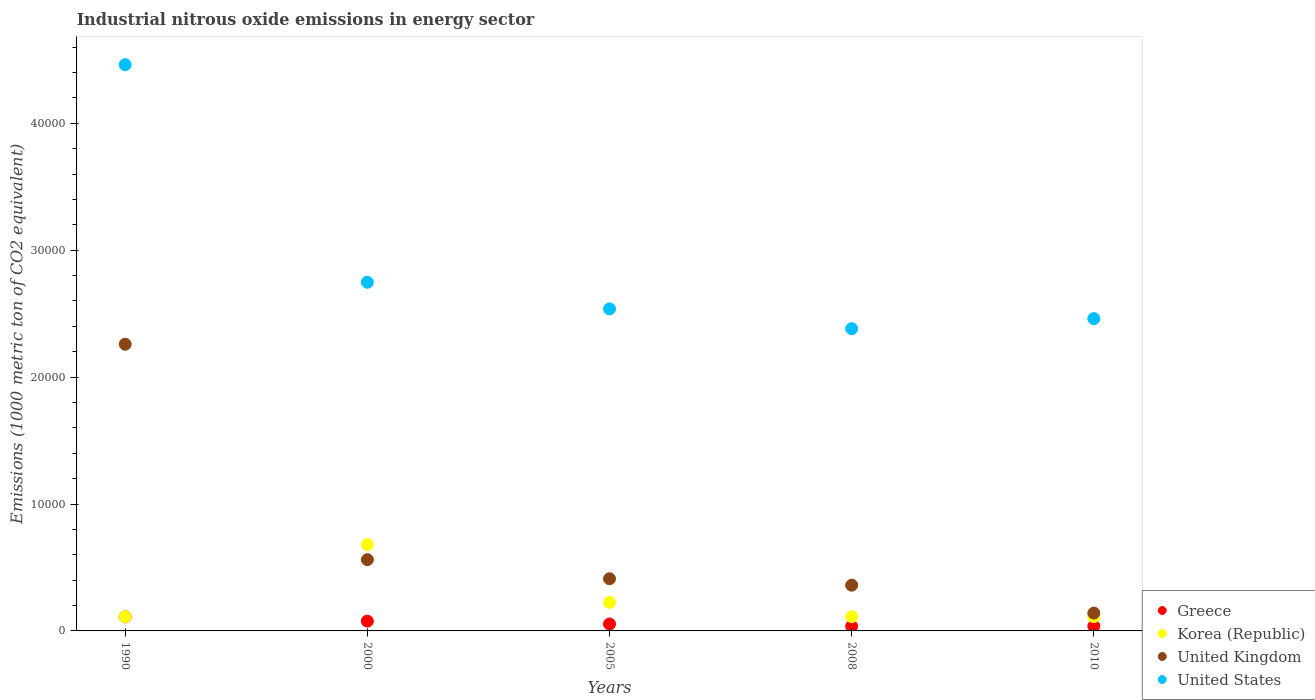How many different coloured dotlines are there?
Make the answer very short. 4. Is the number of dotlines equal to the number of legend labels?
Give a very brief answer. Yes. What is the amount of industrial nitrous oxide emitted in United Kingdom in 2005?
Make the answer very short. 4111.2. Across all years, what is the maximum amount of industrial nitrous oxide emitted in Korea (Republic)?
Ensure brevity in your answer.  6803. Across all years, what is the minimum amount of industrial nitrous oxide emitted in Korea (Republic)?
Provide a short and direct response. 1112.3. In which year was the amount of industrial nitrous oxide emitted in United Kingdom maximum?
Give a very brief answer. 1990. What is the total amount of industrial nitrous oxide emitted in United Kingdom in the graph?
Your response must be concise. 3.73e+04. What is the difference between the amount of industrial nitrous oxide emitted in Korea (Republic) in 2005 and that in 2008?
Make the answer very short. 1125.6. What is the difference between the amount of industrial nitrous oxide emitted in Korea (Republic) in 2005 and the amount of industrial nitrous oxide emitted in United Kingdom in 2010?
Make the answer very short. 840.9. What is the average amount of industrial nitrous oxide emitted in United Kingdom per year?
Offer a very short reply. 7466.28. In the year 2000, what is the difference between the amount of industrial nitrous oxide emitted in Greece and amount of industrial nitrous oxide emitted in Korea (Republic)?
Give a very brief answer. -6032. In how many years, is the amount of industrial nitrous oxide emitted in United Kingdom greater than 8000 1000 metric ton?
Offer a terse response. 1. What is the ratio of the amount of industrial nitrous oxide emitted in Greece in 1990 to that in 2000?
Ensure brevity in your answer.  1.44. Is the difference between the amount of industrial nitrous oxide emitted in Greece in 1990 and 2010 greater than the difference between the amount of industrial nitrous oxide emitted in Korea (Republic) in 1990 and 2010?
Provide a short and direct response. Yes. What is the difference between the highest and the second highest amount of industrial nitrous oxide emitted in United States?
Provide a short and direct response. 1.71e+04. What is the difference between the highest and the lowest amount of industrial nitrous oxide emitted in Greece?
Your answer should be very brief. 741.7. Is the sum of the amount of industrial nitrous oxide emitted in Korea (Republic) in 2000 and 2010 greater than the maximum amount of industrial nitrous oxide emitted in United Kingdom across all years?
Provide a short and direct response. No. Is it the case that in every year, the sum of the amount of industrial nitrous oxide emitted in United States and amount of industrial nitrous oxide emitted in Greece  is greater than the sum of amount of industrial nitrous oxide emitted in United Kingdom and amount of industrial nitrous oxide emitted in Korea (Republic)?
Provide a short and direct response. Yes. Is it the case that in every year, the sum of the amount of industrial nitrous oxide emitted in United Kingdom and amount of industrial nitrous oxide emitted in Greece  is greater than the amount of industrial nitrous oxide emitted in Korea (Republic)?
Keep it short and to the point. No. Is the amount of industrial nitrous oxide emitted in Greece strictly greater than the amount of industrial nitrous oxide emitted in United Kingdom over the years?
Your answer should be compact. No. How many years are there in the graph?
Your answer should be compact. 5. What is the difference between two consecutive major ticks on the Y-axis?
Give a very brief answer. 10000. Are the values on the major ticks of Y-axis written in scientific E-notation?
Give a very brief answer. No. Does the graph contain grids?
Keep it short and to the point. No. How many legend labels are there?
Your answer should be compact. 4. What is the title of the graph?
Provide a short and direct response. Industrial nitrous oxide emissions in energy sector. What is the label or title of the X-axis?
Offer a very short reply. Years. What is the label or title of the Y-axis?
Provide a succinct answer. Emissions (1000 metric ton of CO2 equivalent). What is the Emissions (1000 metric ton of CO2 equivalent) of Greece in 1990?
Your answer should be compact. 1109.1. What is the Emissions (1000 metric ton of CO2 equivalent) in Korea (Republic) in 1990?
Your response must be concise. 1112.3. What is the Emissions (1000 metric ton of CO2 equivalent) in United Kingdom in 1990?
Make the answer very short. 2.26e+04. What is the Emissions (1000 metric ton of CO2 equivalent) in United States in 1990?
Your answer should be compact. 4.46e+04. What is the Emissions (1000 metric ton of CO2 equivalent) in Greece in 2000?
Make the answer very short. 771. What is the Emissions (1000 metric ton of CO2 equivalent) in Korea (Republic) in 2000?
Your answer should be very brief. 6803. What is the Emissions (1000 metric ton of CO2 equivalent) in United Kingdom in 2000?
Keep it short and to the point. 5616. What is the Emissions (1000 metric ton of CO2 equivalent) of United States in 2000?
Provide a succinct answer. 2.75e+04. What is the Emissions (1000 metric ton of CO2 equivalent) in Greece in 2005?
Provide a short and direct response. 545.8. What is the Emissions (1000 metric ton of CO2 equivalent) of Korea (Republic) in 2005?
Your answer should be very brief. 2247.5. What is the Emissions (1000 metric ton of CO2 equivalent) of United Kingdom in 2005?
Make the answer very short. 4111.2. What is the Emissions (1000 metric ton of CO2 equivalent) in United States in 2005?
Make the answer very short. 2.54e+04. What is the Emissions (1000 metric ton of CO2 equivalent) of Greece in 2008?
Provide a short and direct response. 367.4. What is the Emissions (1000 metric ton of CO2 equivalent) of Korea (Republic) in 2008?
Offer a very short reply. 1121.9. What is the Emissions (1000 metric ton of CO2 equivalent) of United Kingdom in 2008?
Give a very brief answer. 3604.6. What is the Emissions (1000 metric ton of CO2 equivalent) of United States in 2008?
Your answer should be very brief. 2.38e+04. What is the Emissions (1000 metric ton of CO2 equivalent) in Greece in 2010?
Offer a terse response. 372.7. What is the Emissions (1000 metric ton of CO2 equivalent) in Korea (Republic) in 2010?
Ensure brevity in your answer.  1122.5. What is the Emissions (1000 metric ton of CO2 equivalent) in United Kingdom in 2010?
Offer a very short reply. 1406.6. What is the Emissions (1000 metric ton of CO2 equivalent) of United States in 2010?
Keep it short and to the point. 2.46e+04. Across all years, what is the maximum Emissions (1000 metric ton of CO2 equivalent) of Greece?
Ensure brevity in your answer.  1109.1. Across all years, what is the maximum Emissions (1000 metric ton of CO2 equivalent) in Korea (Republic)?
Make the answer very short. 6803. Across all years, what is the maximum Emissions (1000 metric ton of CO2 equivalent) in United Kingdom?
Make the answer very short. 2.26e+04. Across all years, what is the maximum Emissions (1000 metric ton of CO2 equivalent) in United States?
Provide a succinct answer. 4.46e+04. Across all years, what is the minimum Emissions (1000 metric ton of CO2 equivalent) in Greece?
Make the answer very short. 367.4. Across all years, what is the minimum Emissions (1000 metric ton of CO2 equivalent) of Korea (Republic)?
Your answer should be compact. 1112.3. Across all years, what is the minimum Emissions (1000 metric ton of CO2 equivalent) in United Kingdom?
Your answer should be compact. 1406.6. Across all years, what is the minimum Emissions (1000 metric ton of CO2 equivalent) of United States?
Your answer should be very brief. 2.38e+04. What is the total Emissions (1000 metric ton of CO2 equivalent) of Greece in the graph?
Your answer should be very brief. 3166. What is the total Emissions (1000 metric ton of CO2 equivalent) of Korea (Republic) in the graph?
Your answer should be very brief. 1.24e+04. What is the total Emissions (1000 metric ton of CO2 equivalent) in United Kingdom in the graph?
Offer a terse response. 3.73e+04. What is the total Emissions (1000 metric ton of CO2 equivalent) of United States in the graph?
Keep it short and to the point. 1.46e+05. What is the difference between the Emissions (1000 metric ton of CO2 equivalent) of Greece in 1990 and that in 2000?
Give a very brief answer. 338.1. What is the difference between the Emissions (1000 metric ton of CO2 equivalent) of Korea (Republic) in 1990 and that in 2000?
Your answer should be compact. -5690.7. What is the difference between the Emissions (1000 metric ton of CO2 equivalent) in United Kingdom in 1990 and that in 2000?
Your response must be concise. 1.70e+04. What is the difference between the Emissions (1000 metric ton of CO2 equivalent) of United States in 1990 and that in 2000?
Your answer should be very brief. 1.71e+04. What is the difference between the Emissions (1000 metric ton of CO2 equivalent) of Greece in 1990 and that in 2005?
Your answer should be very brief. 563.3. What is the difference between the Emissions (1000 metric ton of CO2 equivalent) of Korea (Republic) in 1990 and that in 2005?
Your response must be concise. -1135.2. What is the difference between the Emissions (1000 metric ton of CO2 equivalent) of United Kingdom in 1990 and that in 2005?
Offer a terse response. 1.85e+04. What is the difference between the Emissions (1000 metric ton of CO2 equivalent) of United States in 1990 and that in 2005?
Keep it short and to the point. 1.92e+04. What is the difference between the Emissions (1000 metric ton of CO2 equivalent) of Greece in 1990 and that in 2008?
Provide a succinct answer. 741.7. What is the difference between the Emissions (1000 metric ton of CO2 equivalent) in United Kingdom in 1990 and that in 2008?
Make the answer very short. 1.90e+04. What is the difference between the Emissions (1000 metric ton of CO2 equivalent) of United States in 1990 and that in 2008?
Ensure brevity in your answer.  2.08e+04. What is the difference between the Emissions (1000 metric ton of CO2 equivalent) in Greece in 1990 and that in 2010?
Offer a terse response. 736.4. What is the difference between the Emissions (1000 metric ton of CO2 equivalent) in Korea (Republic) in 1990 and that in 2010?
Provide a succinct answer. -10.2. What is the difference between the Emissions (1000 metric ton of CO2 equivalent) in United Kingdom in 1990 and that in 2010?
Offer a terse response. 2.12e+04. What is the difference between the Emissions (1000 metric ton of CO2 equivalent) of United States in 1990 and that in 2010?
Offer a terse response. 2.00e+04. What is the difference between the Emissions (1000 metric ton of CO2 equivalent) of Greece in 2000 and that in 2005?
Make the answer very short. 225.2. What is the difference between the Emissions (1000 metric ton of CO2 equivalent) of Korea (Republic) in 2000 and that in 2005?
Offer a terse response. 4555.5. What is the difference between the Emissions (1000 metric ton of CO2 equivalent) in United Kingdom in 2000 and that in 2005?
Your answer should be very brief. 1504.8. What is the difference between the Emissions (1000 metric ton of CO2 equivalent) in United States in 2000 and that in 2005?
Ensure brevity in your answer.  2099.2. What is the difference between the Emissions (1000 metric ton of CO2 equivalent) in Greece in 2000 and that in 2008?
Your response must be concise. 403.6. What is the difference between the Emissions (1000 metric ton of CO2 equivalent) in Korea (Republic) in 2000 and that in 2008?
Offer a very short reply. 5681.1. What is the difference between the Emissions (1000 metric ton of CO2 equivalent) of United Kingdom in 2000 and that in 2008?
Ensure brevity in your answer.  2011.4. What is the difference between the Emissions (1000 metric ton of CO2 equivalent) of United States in 2000 and that in 2008?
Your answer should be very brief. 3660.1. What is the difference between the Emissions (1000 metric ton of CO2 equivalent) of Greece in 2000 and that in 2010?
Your answer should be very brief. 398.3. What is the difference between the Emissions (1000 metric ton of CO2 equivalent) in Korea (Republic) in 2000 and that in 2010?
Make the answer very short. 5680.5. What is the difference between the Emissions (1000 metric ton of CO2 equivalent) of United Kingdom in 2000 and that in 2010?
Your answer should be compact. 4209.4. What is the difference between the Emissions (1000 metric ton of CO2 equivalent) in United States in 2000 and that in 2010?
Keep it short and to the point. 2866.4. What is the difference between the Emissions (1000 metric ton of CO2 equivalent) in Greece in 2005 and that in 2008?
Offer a very short reply. 178.4. What is the difference between the Emissions (1000 metric ton of CO2 equivalent) of Korea (Republic) in 2005 and that in 2008?
Keep it short and to the point. 1125.6. What is the difference between the Emissions (1000 metric ton of CO2 equivalent) of United Kingdom in 2005 and that in 2008?
Keep it short and to the point. 506.6. What is the difference between the Emissions (1000 metric ton of CO2 equivalent) of United States in 2005 and that in 2008?
Give a very brief answer. 1560.9. What is the difference between the Emissions (1000 metric ton of CO2 equivalent) in Greece in 2005 and that in 2010?
Make the answer very short. 173.1. What is the difference between the Emissions (1000 metric ton of CO2 equivalent) in Korea (Republic) in 2005 and that in 2010?
Your response must be concise. 1125. What is the difference between the Emissions (1000 metric ton of CO2 equivalent) of United Kingdom in 2005 and that in 2010?
Give a very brief answer. 2704.6. What is the difference between the Emissions (1000 metric ton of CO2 equivalent) of United States in 2005 and that in 2010?
Keep it short and to the point. 767.2. What is the difference between the Emissions (1000 metric ton of CO2 equivalent) of Korea (Republic) in 2008 and that in 2010?
Provide a short and direct response. -0.6. What is the difference between the Emissions (1000 metric ton of CO2 equivalent) of United Kingdom in 2008 and that in 2010?
Provide a short and direct response. 2198. What is the difference between the Emissions (1000 metric ton of CO2 equivalent) of United States in 2008 and that in 2010?
Your answer should be compact. -793.7. What is the difference between the Emissions (1000 metric ton of CO2 equivalent) in Greece in 1990 and the Emissions (1000 metric ton of CO2 equivalent) in Korea (Republic) in 2000?
Give a very brief answer. -5693.9. What is the difference between the Emissions (1000 metric ton of CO2 equivalent) in Greece in 1990 and the Emissions (1000 metric ton of CO2 equivalent) in United Kingdom in 2000?
Offer a terse response. -4506.9. What is the difference between the Emissions (1000 metric ton of CO2 equivalent) in Greece in 1990 and the Emissions (1000 metric ton of CO2 equivalent) in United States in 2000?
Offer a very short reply. -2.64e+04. What is the difference between the Emissions (1000 metric ton of CO2 equivalent) of Korea (Republic) in 1990 and the Emissions (1000 metric ton of CO2 equivalent) of United Kingdom in 2000?
Your answer should be very brief. -4503.7. What is the difference between the Emissions (1000 metric ton of CO2 equivalent) of Korea (Republic) in 1990 and the Emissions (1000 metric ton of CO2 equivalent) of United States in 2000?
Keep it short and to the point. -2.64e+04. What is the difference between the Emissions (1000 metric ton of CO2 equivalent) in United Kingdom in 1990 and the Emissions (1000 metric ton of CO2 equivalent) in United States in 2000?
Offer a very short reply. -4884.9. What is the difference between the Emissions (1000 metric ton of CO2 equivalent) in Greece in 1990 and the Emissions (1000 metric ton of CO2 equivalent) in Korea (Republic) in 2005?
Offer a very short reply. -1138.4. What is the difference between the Emissions (1000 metric ton of CO2 equivalent) of Greece in 1990 and the Emissions (1000 metric ton of CO2 equivalent) of United Kingdom in 2005?
Provide a succinct answer. -3002.1. What is the difference between the Emissions (1000 metric ton of CO2 equivalent) of Greece in 1990 and the Emissions (1000 metric ton of CO2 equivalent) of United States in 2005?
Make the answer very short. -2.43e+04. What is the difference between the Emissions (1000 metric ton of CO2 equivalent) in Korea (Republic) in 1990 and the Emissions (1000 metric ton of CO2 equivalent) in United Kingdom in 2005?
Provide a succinct answer. -2998.9. What is the difference between the Emissions (1000 metric ton of CO2 equivalent) of Korea (Republic) in 1990 and the Emissions (1000 metric ton of CO2 equivalent) of United States in 2005?
Provide a short and direct response. -2.43e+04. What is the difference between the Emissions (1000 metric ton of CO2 equivalent) in United Kingdom in 1990 and the Emissions (1000 metric ton of CO2 equivalent) in United States in 2005?
Offer a terse response. -2785.7. What is the difference between the Emissions (1000 metric ton of CO2 equivalent) of Greece in 1990 and the Emissions (1000 metric ton of CO2 equivalent) of United Kingdom in 2008?
Make the answer very short. -2495.5. What is the difference between the Emissions (1000 metric ton of CO2 equivalent) in Greece in 1990 and the Emissions (1000 metric ton of CO2 equivalent) in United States in 2008?
Your answer should be very brief. -2.27e+04. What is the difference between the Emissions (1000 metric ton of CO2 equivalent) of Korea (Republic) in 1990 and the Emissions (1000 metric ton of CO2 equivalent) of United Kingdom in 2008?
Your answer should be compact. -2492.3. What is the difference between the Emissions (1000 metric ton of CO2 equivalent) in Korea (Republic) in 1990 and the Emissions (1000 metric ton of CO2 equivalent) in United States in 2008?
Give a very brief answer. -2.27e+04. What is the difference between the Emissions (1000 metric ton of CO2 equivalent) of United Kingdom in 1990 and the Emissions (1000 metric ton of CO2 equivalent) of United States in 2008?
Your answer should be very brief. -1224.8. What is the difference between the Emissions (1000 metric ton of CO2 equivalent) of Greece in 1990 and the Emissions (1000 metric ton of CO2 equivalent) of United Kingdom in 2010?
Keep it short and to the point. -297.5. What is the difference between the Emissions (1000 metric ton of CO2 equivalent) of Greece in 1990 and the Emissions (1000 metric ton of CO2 equivalent) of United States in 2010?
Your answer should be very brief. -2.35e+04. What is the difference between the Emissions (1000 metric ton of CO2 equivalent) in Korea (Republic) in 1990 and the Emissions (1000 metric ton of CO2 equivalent) in United Kingdom in 2010?
Your answer should be compact. -294.3. What is the difference between the Emissions (1000 metric ton of CO2 equivalent) in Korea (Republic) in 1990 and the Emissions (1000 metric ton of CO2 equivalent) in United States in 2010?
Offer a terse response. -2.35e+04. What is the difference between the Emissions (1000 metric ton of CO2 equivalent) of United Kingdom in 1990 and the Emissions (1000 metric ton of CO2 equivalent) of United States in 2010?
Your answer should be very brief. -2018.5. What is the difference between the Emissions (1000 metric ton of CO2 equivalent) in Greece in 2000 and the Emissions (1000 metric ton of CO2 equivalent) in Korea (Republic) in 2005?
Offer a terse response. -1476.5. What is the difference between the Emissions (1000 metric ton of CO2 equivalent) of Greece in 2000 and the Emissions (1000 metric ton of CO2 equivalent) of United Kingdom in 2005?
Offer a terse response. -3340.2. What is the difference between the Emissions (1000 metric ton of CO2 equivalent) of Greece in 2000 and the Emissions (1000 metric ton of CO2 equivalent) of United States in 2005?
Offer a terse response. -2.46e+04. What is the difference between the Emissions (1000 metric ton of CO2 equivalent) of Korea (Republic) in 2000 and the Emissions (1000 metric ton of CO2 equivalent) of United Kingdom in 2005?
Offer a terse response. 2691.8. What is the difference between the Emissions (1000 metric ton of CO2 equivalent) of Korea (Republic) in 2000 and the Emissions (1000 metric ton of CO2 equivalent) of United States in 2005?
Your response must be concise. -1.86e+04. What is the difference between the Emissions (1000 metric ton of CO2 equivalent) of United Kingdom in 2000 and the Emissions (1000 metric ton of CO2 equivalent) of United States in 2005?
Your answer should be very brief. -1.98e+04. What is the difference between the Emissions (1000 metric ton of CO2 equivalent) of Greece in 2000 and the Emissions (1000 metric ton of CO2 equivalent) of Korea (Republic) in 2008?
Provide a succinct answer. -350.9. What is the difference between the Emissions (1000 metric ton of CO2 equivalent) in Greece in 2000 and the Emissions (1000 metric ton of CO2 equivalent) in United Kingdom in 2008?
Ensure brevity in your answer.  -2833.6. What is the difference between the Emissions (1000 metric ton of CO2 equivalent) in Greece in 2000 and the Emissions (1000 metric ton of CO2 equivalent) in United States in 2008?
Offer a very short reply. -2.30e+04. What is the difference between the Emissions (1000 metric ton of CO2 equivalent) in Korea (Republic) in 2000 and the Emissions (1000 metric ton of CO2 equivalent) in United Kingdom in 2008?
Keep it short and to the point. 3198.4. What is the difference between the Emissions (1000 metric ton of CO2 equivalent) of Korea (Republic) in 2000 and the Emissions (1000 metric ton of CO2 equivalent) of United States in 2008?
Your answer should be very brief. -1.70e+04. What is the difference between the Emissions (1000 metric ton of CO2 equivalent) of United Kingdom in 2000 and the Emissions (1000 metric ton of CO2 equivalent) of United States in 2008?
Your answer should be compact. -1.82e+04. What is the difference between the Emissions (1000 metric ton of CO2 equivalent) of Greece in 2000 and the Emissions (1000 metric ton of CO2 equivalent) of Korea (Republic) in 2010?
Offer a terse response. -351.5. What is the difference between the Emissions (1000 metric ton of CO2 equivalent) of Greece in 2000 and the Emissions (1000 metric ton of CO2 equivalent) of United Kingdom in 2010?
Ensure brevity in your answer.  -635.6. What is the difference between the Emissions (1000 metric ton of CO2 equivalent) in Greece in 2000 and the Emissions (1000 metric ton of CO2 equivalent) in United States in 2010?
Ensure brevity in your answer.  -2.38e+04. What is the difference between the Emissions (1000 metric ton of CO2 equivalent) of Korea (Republic) in 2000 and the Emissions (1000 metric ton of CO2 equivalent) of United Kingdom in 2010?
Your response must be concise. 5396.4. What is the difference between the Emissions (1000 metric ton of CO2 equivalent) in Korea (Republic) in 2000 and the Emissions (1000 metric ton of CO2 equivalent) in United States in 2010?
Your answer should be very brief. -1.78e+04. What is the difference between the Emissions (1000 metric ton of CO2 equivalent) in United Kingdom in 2000 and the Emissions (1000 metric ton of CO2 equivalent) in United States in 2010?
Provide a succinct answer. -1.90e+04. What is the difference between the Emissions (1000 metric ton of CO2 equivalent) in Greece in 2005 and the Emissions (1000 metric ton of CO2 equivalent) in Korea (Republic) in 2008?
Your response must be concise. -576.1. What is the difference between the Emissions (1000 metric ton of CO2 equivalent) of Greece in 2005 and the Emissions (1000 metric ton of CO2 equivalent) of United Kingdom in 2008?
Provide a short and direct response. -3058.8. What is the difference between the Emissions (1000 metric ton of CO2 equivalent) of Greece in 2005 and the Emissions (1000 metric ton of CO2 equivalent) of United States in 2008?
Provide a succinct answer. -2.33e+04. What is the difference between the Emissions (1000 metric ton of CO2 equivalent) in Korea (Republic) in 2005 and the Emissions (1000 metric ton of CO2 equivalent) in United Kingdom in 2008?
Your response must be concise. -1357.1. What is the difference between the Emissions (1000 metric ton of CO2 equivalent) in Korea (Republic) in 2005 and the Emissions (1000 metric ton of CO2 equivalent) in United States in 2008?
Offer a very short reply. -2.16e+04. What is the difference between the Emissions (1000 metric ton of CO2 equivalent) of United Kingdom in 2005 and the Emissions (1000 metric ton of CO2 equivalent) of United States in 2008?
Offer a terse response. -1.97e+04. What is the difference between the Emissions (1000 metric ton of CO2 equivalent) in Greece in 2005 and the Emissions (1000 metric ton of CO2 equivalent) in Korea (Republic) in 2010?
Keep it short and to the point. -576.7. What is the difference between the Emissions (1000 metric ton of CO2 equivalent) of Greece in 2005 and the Emissions (1000 metric ton of CO2 equivalent) of United Kingdom in 2010?
Your answer should be very brief. -860.8. What is the difference between the Emissions (1000 metric ton of CO2 equivalent) in Greece in 2005 and the Emissions (1000 metric ton of CO2 equivalent) in United States in 2010?
Your answer should be very brief. -2.41e+04. What is the difference between the Emissions (1000 metric ton of CO2 equivalent) of Korea (Republic) in 2005 and the Emissions (1000 metric ton of CO2 equivalent) of United Kingdom in 2010?
Ensure brevity in your answer.  840.9. What is the difference between the Emissions (1000 metric ton of CO2 equivalent) of Korea (Republic) in 2005 and the Emissions (1000 metric ton of CO2 equivalent) of United States in 2010?
Provide a succinct answer. -2.24e+04. What is the difference between the Emissions (1000 metric ton of CO2 equivalent) in United Kingdom in 2005 and the Emissions (1000 metric ton of CO2 equivalent) in United States in 2010?
Ensure brevity in your answer.  -2.05e+04. What is the difference between the Emissions (1000 metric ton of CO2 equivalent) of Greece in 2008 and the Emissions (1000 metric ton of CO2 equivalent) of Korea (Republic) in 2010?
Offer a very short reply. -755.1. What is the difference between the Emissions (1000 metric ton of CO2 equivalent) in Greece in 2008 and the Emissions (1000 metric ton of CO2 equivalent) in United Kingdom in 2010?
Ensure brevity in your answer.  -1039.2. What is the difference between the Emissions (1000 metric ton of CO2 equivalent) of Greece in 2008 and the Emissions (1000 metric ton of CO2 equivalent) of United States in 2010?
Provide a succinct answer. -2.42e+04. What is the difference between the Emissions (1000 metric ton of CO2 equivalent) of Korea (Republic) in 2008 and the Emissions (1000 metric ton of CO2 equivalent) of United Kingdom in 2010?
Your answer should be compact. -284.7. What is the difference between the Emissions (1000 metric ton of CO2 equivalent) in Korea (Republic) in 2008 and the Emissions (1000 metric ton of CO2 equivalent) in United States in 2010?
Ensure brevity in your answer.  -2.35e+04. What is the difference between the Emissions (1000 metric ton of CO2 equivalent) in United Kingdom in 2008 and the Emissions (1000 metric ton of CO2 equivalent) in United States in 2010?
Provide a succinct answer. -2.10e+04. What is the average Emissions (1000 metric ton of CO2 equivalent) in Greece per year?
Your response must be concise. 633.2. What is the average Emissions (1000 metric ton of CO2 equivalent) of Korea (Republic) per year?
Keep it short and to the point. 2481.44. What is the average Emissions (1000 metric ton of CO2 equivalent) of United Kingdom per year?
Offer a very short reply. 7466.28. What is the average Emissions (1000 metric ton of CO2 equivalent) in United States per year?
Provide a short and direct response. 2.92e+04. In the year 1990, what is the difference between the Emissions (1000 metric ton of CO2 equivalent) of Greece and Emissions (1000 metric ton of CO2 equivalent) of United Kingdom?
Your response must be concise. -2.15e+04. In the year 1990, what is the difference between the Emissions (1000 metric ton of CO2 equivalent) in Greece and Emissions (1000 metric ton of CO2 equivalent) in United States?
Offer a very short reply. -4.35e+04. In the year 1990, what is the difference between the Emissions (1000 metric ton of CO2 equivalent) in Korea (Republic) and Emissions (1000 metric ton of CO2 equivalent) in United Kingdom?
Ensure brevity in your answer.  -2.15e+04. In the year 1990, what is the difference between the Emissions (1000 metric ton of CO2 equivalent) in Korea (Republic) and Emissions (1000 metric ton of CO2 equivalent) in United States?
Your answer should be very brief. -4.35e+04. In the year 1990, what is the difference between the Emissions (1000 metric ton of CO2 equivalent) of United Kingdom and Emissions (1000 metric ton of CO2 equivalent) of United States?
Make the answer very short. -2.20e+04. In the year 2000, what is the difference between the Emissions (1000 metric ton of CO2 equivalent) in Greece and Emissions (1000 metric ton of CO2 equivalent) in Korea (Republic)?
Provide a short and direct response. -6032. In the year 2000, what is the difference between the Emissions (1000 metric ton of CO2 equivalent) in Greece and Emissions (1000 metric ton of CO2 equivalent) in United Kingdom?
Offer a terse response. -4845. In the year 2000, what is the difference between the Emissions (1000 metric ton of CO2 equivalent) in Greece and Emissions (1000 metric ton of CO2 equivalent) in United States?
Provide a succinct answer. -2.67e+04. In the year 2000, what is the difference between the Emissions (1000 metric ton of CO2 equivalent) of Korea (Republic) and Emissions (1000 metric ton of CO2 equivalent) of United Kingdom?
Ensure brevity in your answer.  1187. In the year 2000, what is the difference between the Emissions (1000 metric ton of CO2 equivalent) in Korea (Republic) and Emissions (1000 metric ton of CO2 equivalent) in United States?
Make the answer very short. -2.07e+04. In the year 2000, what is the difference between the Emissions (1000 metric ton of CO2 equivalent) of United Kingdom and Emissions (1000 metric ton of CO2 equivalent) of United States?
Your response must be concise. -2.19e+04. In the year 2005, what is the difference between the Emissions (1000 metric ton of CO2 equivalent) of Greece and Emissions (1000 metric ton of CO2 equivalent) of Korea (Republic)?
Give a very brief answer. -1701.7. In the year 2005, what is the difference between the Emissions (1000 metric ton of CO2 equivalent) of Greece and Emissions (1000 metric ton of CO2 equivalent) of United Kingdom?
Provide a succinct answer. -3565.4. In the year 2005, what is the difference between the Emissions (1000 metric ton of CO2 equivalent) of Greece and Emissions (1000 metric ton of CO2 equivalent) of United States?
Your response must be concise. -2.48e+04. In the year 2005, what is the difference between the Emissions (1000 metric ton of CO2 equivalent) in Korea (Republic) and Emissions (1000 metric ton of CO2 equivalent) in United Kingdom?
Provide a succinct answer. -1863.7. In the year 2005, what is the difference between the Emissions (1000 metric ton of CO2 equivalent) in Korea (Republic) and Emissions (1000 metric ton of CO2 equivalent) in United States?
Offer a very short reply. -2.31e+04. In the year 2005, what is the difference between the Emissions (1000 metric ton of CO2 equivalent) of United Kingdom and Emissions (1000 metric ton of CO2 equivalent) of United States?
Keep it short and to the point. -2.13e+04. In the year 2008, what is the difference between the Emissions (1000 metric ton of CO2 equivalent) in Greece and Emissions (1000 metric ton of CO2 equivalent) in Korea (Republic)?
Provide a succinct answer. -754.5. In the year 2008, what is the difference between the Emissions (1000 metric ton of CO2 equivalent) in Greece and Emissions (1000 metric ton of CO2 equivalent) in United Kingdom?
Ensure brevity in your answer.  -3237.2. In the year 2008, what is the difference between the Emissions (1000 metric ton of CO2 equivalent) of Greece and Emissions (1000 metric ton of CO2 equivalent) of United States?
Offer a terse response. -2.35e+04. In the year 2008, what is the difference between the Emissions (1000 metric ton of CO2 equivalent) of Korea (Republic) and Emissions (1000 metric ton of CO2 equivalent) of United Kingdom?
Your response must be concise. -2482.7. In the year 2008, what is the difference between the Emissions (1000 metric ton of CO2 equivalent) of Korea (Republic) and Emissions (1000 metric ton of CO2 equivalent) of United States?
Your answer should be very brief. -2.27e+04. In the year 2008, what is the difference between the Emissions (1000 metric ton of CO2 equivalent) in United Kingdom and Emissions (1000 metric ton of CO2 equivalent) in United States?
Keep it short and to the point. -2.02e+04. In the year 2010, what is the difference between the Emissions (1000 metric ton of CO2 equivalent) in Greece and Emissions (1000 metric ton of CO2 equivalent) in Korea (Republic)?
Ensure brevity in your answer.  -749.8. In the year 2010, what is the difference between the Emissions (1000 metric ton of CO2 equivalent) in Greece and Emissions (1000 metric ton of CO2 equivalent) in United Kingdom?
Give a very brief answer. -1033.9. In the year 2010, what is the difference between the Emissions (1000 metric ton of CO2 equivalent) in Greece and Emissions (1000 metric ton of CO2 equivalent) in United States?
Offer a terse response. -2.42e+04. In the year 2010, what is the difference between the Emissions (1000 metric ton of CO2 equivalent) of Korea (Republic) and Emissions (1000 metric ton of CO2 equivalent) of United Kingdom?
Offer a very short reply. -284.1. In the year 2010, what is the difference between the Emissions (1000 metric ton of CO2 equivalent) in Korea (Republic) and Emissions (1000 metric ton of CO2 equivalent) in United States?
Ensure brevity in your answer.  -2.35e+04. In the year 2010, what is the difference between the Emissions (1000 metric ton of CO2 equivalent) in United Kingdom and Emissions (1000 metric ton of CO2 equivalent) in United States?
Your answer should be compact. -2.32e+04. What is the ratio of the Emissions (1000 metric ton of CO2 equivalent) in Greece in 1990 to that in 2000?
Make the answer very short. 1.44. What is the ratio of the Emissions (1000 metric ton of CO2 equivalent) of Korea (Republic) in 1990 to that in 2000?
Keep it short and to the point. 0.16. What is the ratio of the Emissions (1000 metric ton of CO2 equivalent) in United Kingdom in 1990 to that in 2000?
Offer a terse response. 4.02. What is the ratio of the Emissions (1000 metric ton of CO2 equivalent) in United States in 1990 to that in 2000?
Your response must be concise. 1.62. What is the ratio of the Emissions (1000 metric ton of CO2 equivalent) in Greece in 1990 to that in 2005?
Provide a succinct answer. 2.03. What is the ratio of the Emissions (1000 metric ton of CO2 equivalent) in Korea (Republic) in 1990 to that in 2005?
Your answer should be very brief. 0.49. What is the ratio of the Emissions (1000 metric ton of CO2 equivalent) of United Kingdom in 1990 to that in 2005?
Offer a terse response. 5.5. What is the ratio of the Emissions (1000 metric ton of CO2 equivalent) of United States in 1990 to that in 2005?
Make the answer very short. 1.76. What is the ratio of the Emissions (1000 metric ton of CO2 equivalent) in Greece in 1990 to that in 2008?
Provide a short and direct response. 3.02. What is the ratio of the Emissions (1000 metric ton of CO2 equivalent) in United Kingdom in 1990 to that in 2008?
Make the answer very short. 6.27. What is the ratio of the Emissions (1000 metric ton of CO2 equivalent) of United States in 1990 to that in 2008?
Your answer should be compact. 1.87. What is the ratio of the Emissions (1000 metric ton of CO2 equivalent) of Greece in 1990 to that in 2010?
Offer a terse response. 2.98. What is the ratio of the Emissions (1000 metric ton of CO2 equivalent) of Korea (Republic) in 1990 to that in 2010?
Provide a short and direct response. 0.99. What is the ratio of the Emissions (1000 metric ton of CO2 equivalent) of United Kingdom in 1990 to that in 2010?
Make the answer very short. 16.06. What is the ratio of the Emissions (1000 metric ton of CO2 equivalent) in United States in 1990 to that in 2010?
Your response must be concise. 1.81. What is the ratio of the Emissions (1000 metric ton of CO2 equivalent) in Greece in 2000 to that in 2005?
Give a very brief answer. 1.41. What is the ratio of the Emissions (1000 metric ton of CO2 equivalent) of Korea (Republic) in 2000 to that in 2005?
Your answer should be compact. 3.03. What is the ratio of the Emissions (1000 metric ton of CO2 equivalent) of United Kingdom in 2000 to that in 2005?
Offer a terse response. 1.37. What is the ratio of the Emissions (1000 metric ton of CO2 equivalent) in United States in 2000 to that in 2005?
Your answer should be very brief. 1.08. What is the ratio of the Emissions (1000 metric ton of CO2 equivalent) of Greece in 2000 to that in 2008?
Provide a short and direct response. 2.1. What is the ratio of the Emissions (1000 metric ton of CO2 equivalent) in Korea (Republic) in 2000 to that in 2008?
Keep it short and to the point. 6.06. What is the ratio of the Emissions (1000 metric ton of CO2 equivalent) of United Kingdom in 2000 to that in 2008?
Provide a succinct answer. 1.56. What is the ratio of the Emissions (1000 metric ton of CO2 equivalent) of United States in 2000 to that in 2008?
Your answer should be compact. 1.15. What is the ratio of the Emissions (1000 metric ton of CO2 equivalent) of Greece in 2000 to that in 2010?
Ensure brevity in your answer.  2.07. What is the ratio of the Emissions (1000 metric ton of CO2 equivalent) of Korea (Republic) in 2000 to that in 2010?
Your answer should be very brief. 6.06. What is the ratio of the Emissions (1000 metric ton of CO2 equivalent) in United Kingdom in 2000 to that in 2010?
Provide a succinct answer. 3.99. What is the ratio of the Emissions (1000 metric ton of CO2 equivalent) of United States in 2000 to that in 2010?
Make the answer very short. 1.12. What is the ratio of the Emissions (1000 metric ton of CO2 equivalent) of Greece in 2005 to that in 2008?
Make the answer very short. 1.49. What is the ratio of the Emissions (1000 metric ton of CO2 equivalent) of Korea (Republic) in 2005 to that in 2008?
Your answer should be compact. 2. What is the ratio of the Emissions (1000 metric ton of CO2 equivalent) in United Kingdom in 2005 to that in 2008?
Make the answer very short. 1.14. What is the ratio of the Emissions (1000 metric ton of CO2 equivalent) of United States in 2005 to that in 2008?
Ensure brevity in your answer.  1.07. What is the ratio of the Emissions (1000 metric ton of CO2 equivalent) of Greece in 2005 to that in 2010?
Make the answer very short. 1.46. What is the ratio of the Emissions (1000 metric ton of CO2 equivalent) in Korea (Republic) in 2005 to that in 2010?
Keep it short and to the point. 2. What is the ratio of the Emissions (1000 metric ton of CO2 equivalent) of United Kingdom in 2005 to that in 2010?
Keep it short and to the point. 2.92. What is the ratio of the Emissions (1000 metric ton of CO2 equivalent) in United States in 2005 to that in 2010?
Offer a very short reply. 1.03. What is the ratio of the Emissions (1000 metric ton of CO2 equivalent) of Greece in 2008 to that in 2010?
Offer a very short reply. 0.99. What is the ratio of the Emissions (1000 metric ton of CO2 equivalent) of United Kingdom in 2008 to that in 2010?
Provide a succinct answer. 2.56. What is the ratio of the Emissions (1000 metric ton of CO2 equivalent) in United States in 2008 to that in 2010?
Keep it short and to the point. 0.97. What is the difference between the highest and the second highest Emissions (1000 metric ton of CO2 equivalent) of Greece?
Your answer should be compact. 338.1. What is the difference between the highest and the second highest Emissions (1000 metric ton of CO2 equivalent) in Korea (Republic)?
Provide a short and direct response. 4555.5. What is the difference between the highest and the second highest Emissions (1000 metric ton of CO2 equivalent) of United Kingdom?
Provide a succinct answer. 1.70e+04. What is the difference between the highest and the second highest Emissions (1000 metric ton of CO2 equivalent) in United States?
Provide a short and direct response. 1.71e+04. What is the difference between the highest and the lowest Emissions (1000 metric ton of CO2 equivalent) in Greece?
Provide a succinct answer. 741.7. What is the difference between the highest and the lowest Emissions (1000 metric ton of CO2 equivalent) in Korea (Republic)?
Offer a very short reply. 5690.7. What is the difference between the highest and the lowest Emissions (1000 metric ton of CO2 equivalent) of United Kingdom?
Make the answer very short. 2.12e+04. What is the difference between the highest and the lowest Emissions (1000 metric ton of CO2 equivalent) in United States?
Offer a terse response. 2.08e+04. 